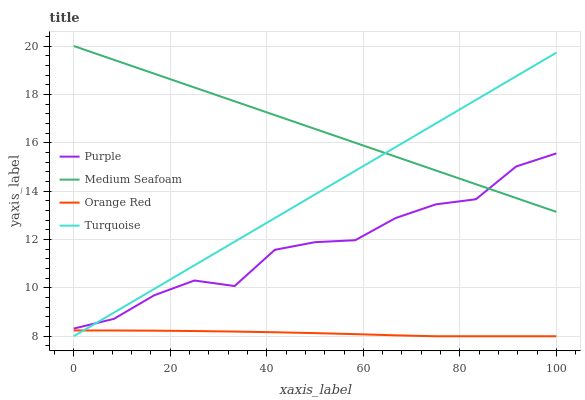Does Orange Red have the minimum area under the curve?
Answer yes or no. Yes. Does Medium Seafoam have the maximum area under the curve?
Answer yes or no. Yes. Does Turquoise have the minimum area under the curve?
Answer yes or no. No. Does Turquoise have the maximum area under the curve?
Answer yes or no. No. Is Medium Seafoam the smoothest?
Answer yes or no. Yes. Is Purple the roughest?
Answer yes or no. Yes. Is Turquoise the smoothest?
Answer yes or no. No. Is Turquoise the roughest?
Answer yes or no. No. Does Turquoise have the lowest value?
Answer yes or no. Yes. Does Medium Seafoam have the lowest value?
Answer yes or no. No. Does Medium Seafoam have the highest value?
Answer yes or no. Yes. Does Turquoise have the highest value?
Answer yes or no. No. Is Orange Red less than Purple?
Answer yes or no. Yes. Is Purple greater than Orange Red?
Answer yes or no. Yes. Does Medium Seafoam intersect Purple?
Answer yes or no. Yes. Is Medium Seafoam less than Purple?
Answer yes or no. No. Is Medium Seafoam greater than Purple?
Answer yes or no. No. Does Orange Red intersect Purple?
Answer yes or no. No. 